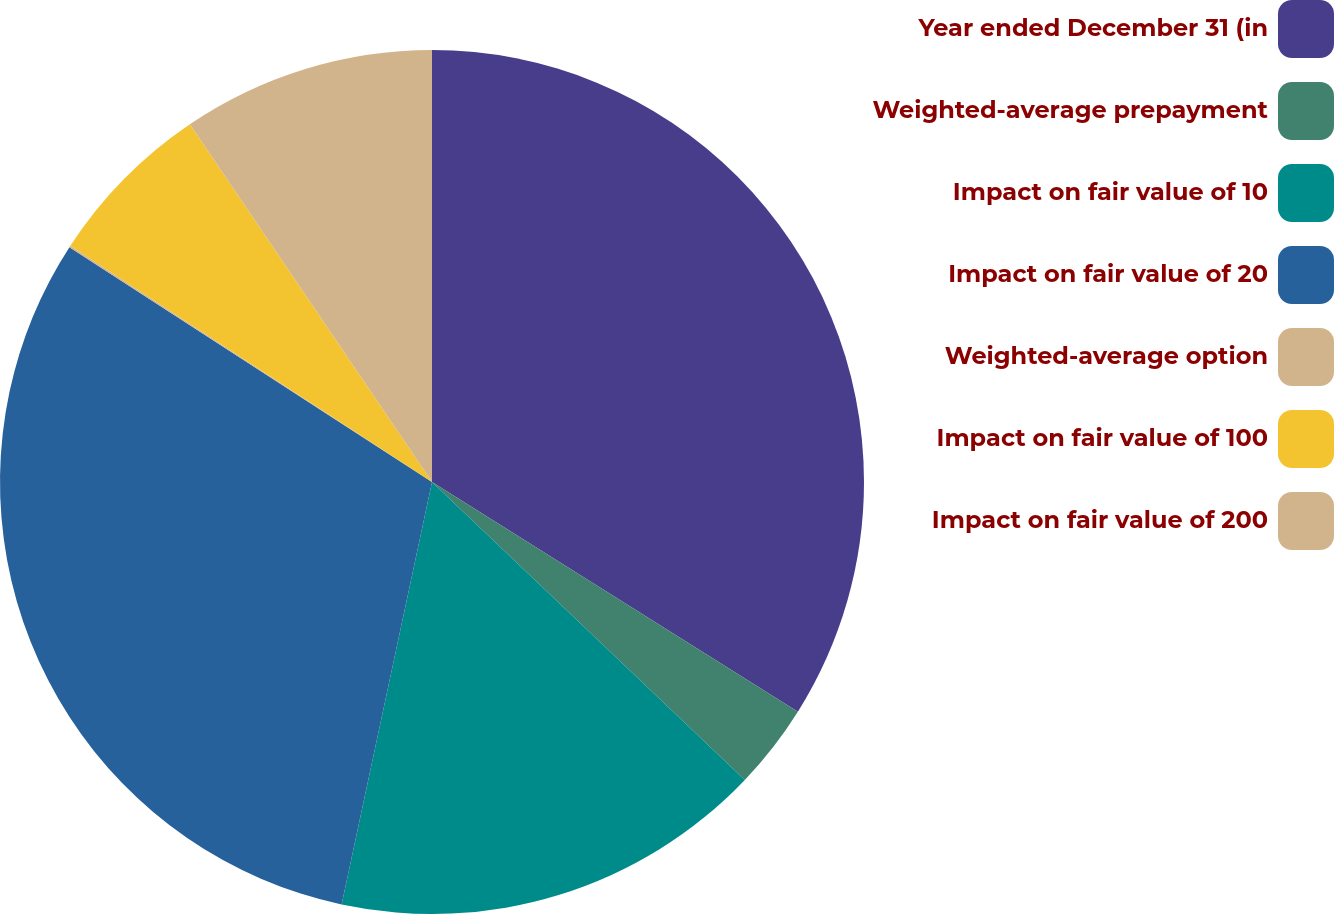Convert chart to OTSL. <chart><loc_0><loc_0><loc_500><loc_500><pie_chart><fcel>Year ended December 31 (in<fcel>Weighted-average prepayment<fcel>Impact on fair value of 10<fcel>Impact on fair value of 20<fcel>Weighted-average option<fcel>Impact on fair value of 100<fcel>Impact on fair value of 200<nl><fcel>33.92%<fcel>3.19%<fcel>16.24%<fcel>30.79%<fcel>0.06%<fcel>6.32%<fcel>9.47%<nl></chart> 